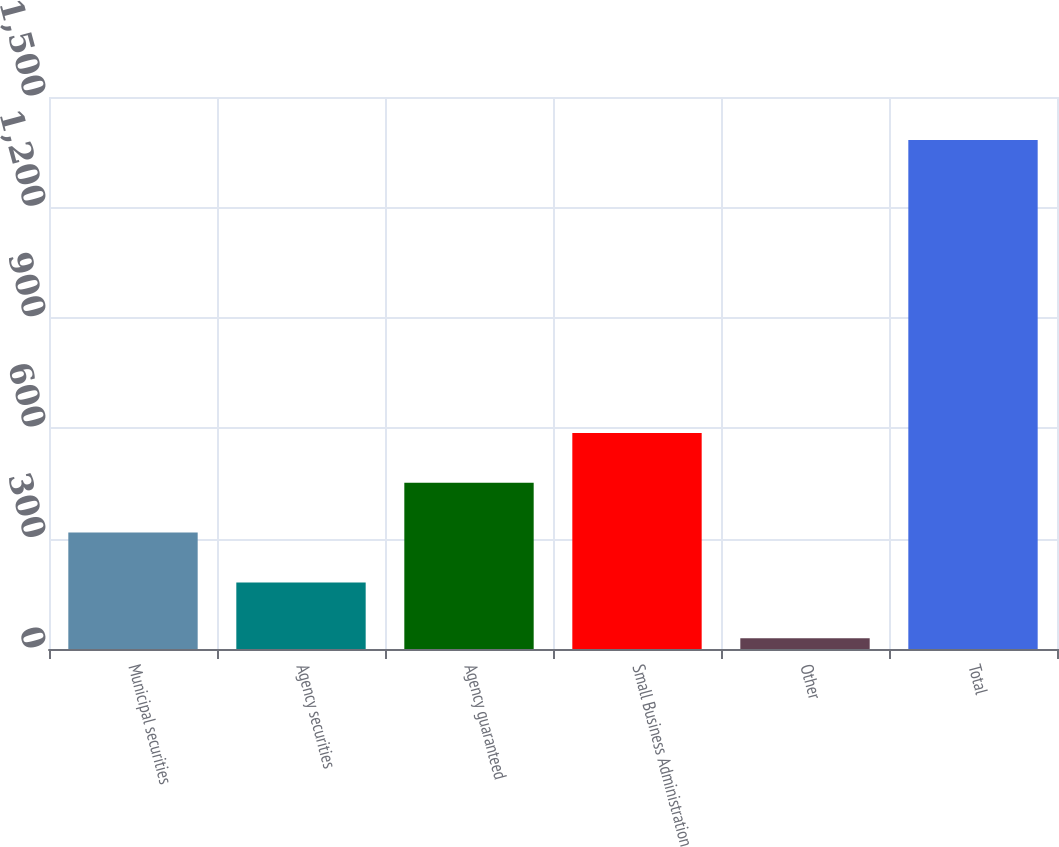Convert chart to OTSL. <chart><loc_0><loc_0><loc_500><loc_500><bar_chart><fcel>Municipal securities<fcel>Agency securities<fcel>Agency guaranteed<fcel>Small Business Administration<fcel>Other<fcel>Total<nl><fcel>316.4<fcel>181<fcel>451.8<fcel>587.2<fcel>29<fcel>1383<nl></chart> 